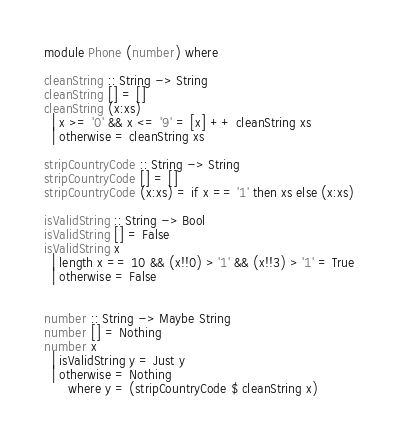Convert code to text. <code><loc_0><loc_0><loc_500><loc_500><_Haskell_>module Phone (number) where

cleanString :: String -> String
cleanString [] = []
cleanString (x:xs)
  | x >= '0' && x <= '9' = [x] ++ cleanString xs
  | otherwise = cleanString xs

stripCountryCode :: String -> String
stripCountryCode [] = []
stripCountryCode (x:xs) = if x == '1' then xs else (x:xs)

isValidString :: String -> Bool
isValidString [] = False
isValidString x
  | length x == 10 && (x!!0) > '1' && (x!!3) > '1' = True
  | otherwise = False


number :: String -> Maybe String
number [] = Nothing
number x
  | isValidString y = Just y
  | otherwise = Nothing
      where y = (stripCountryCode $ cleanString x) 
</code> 